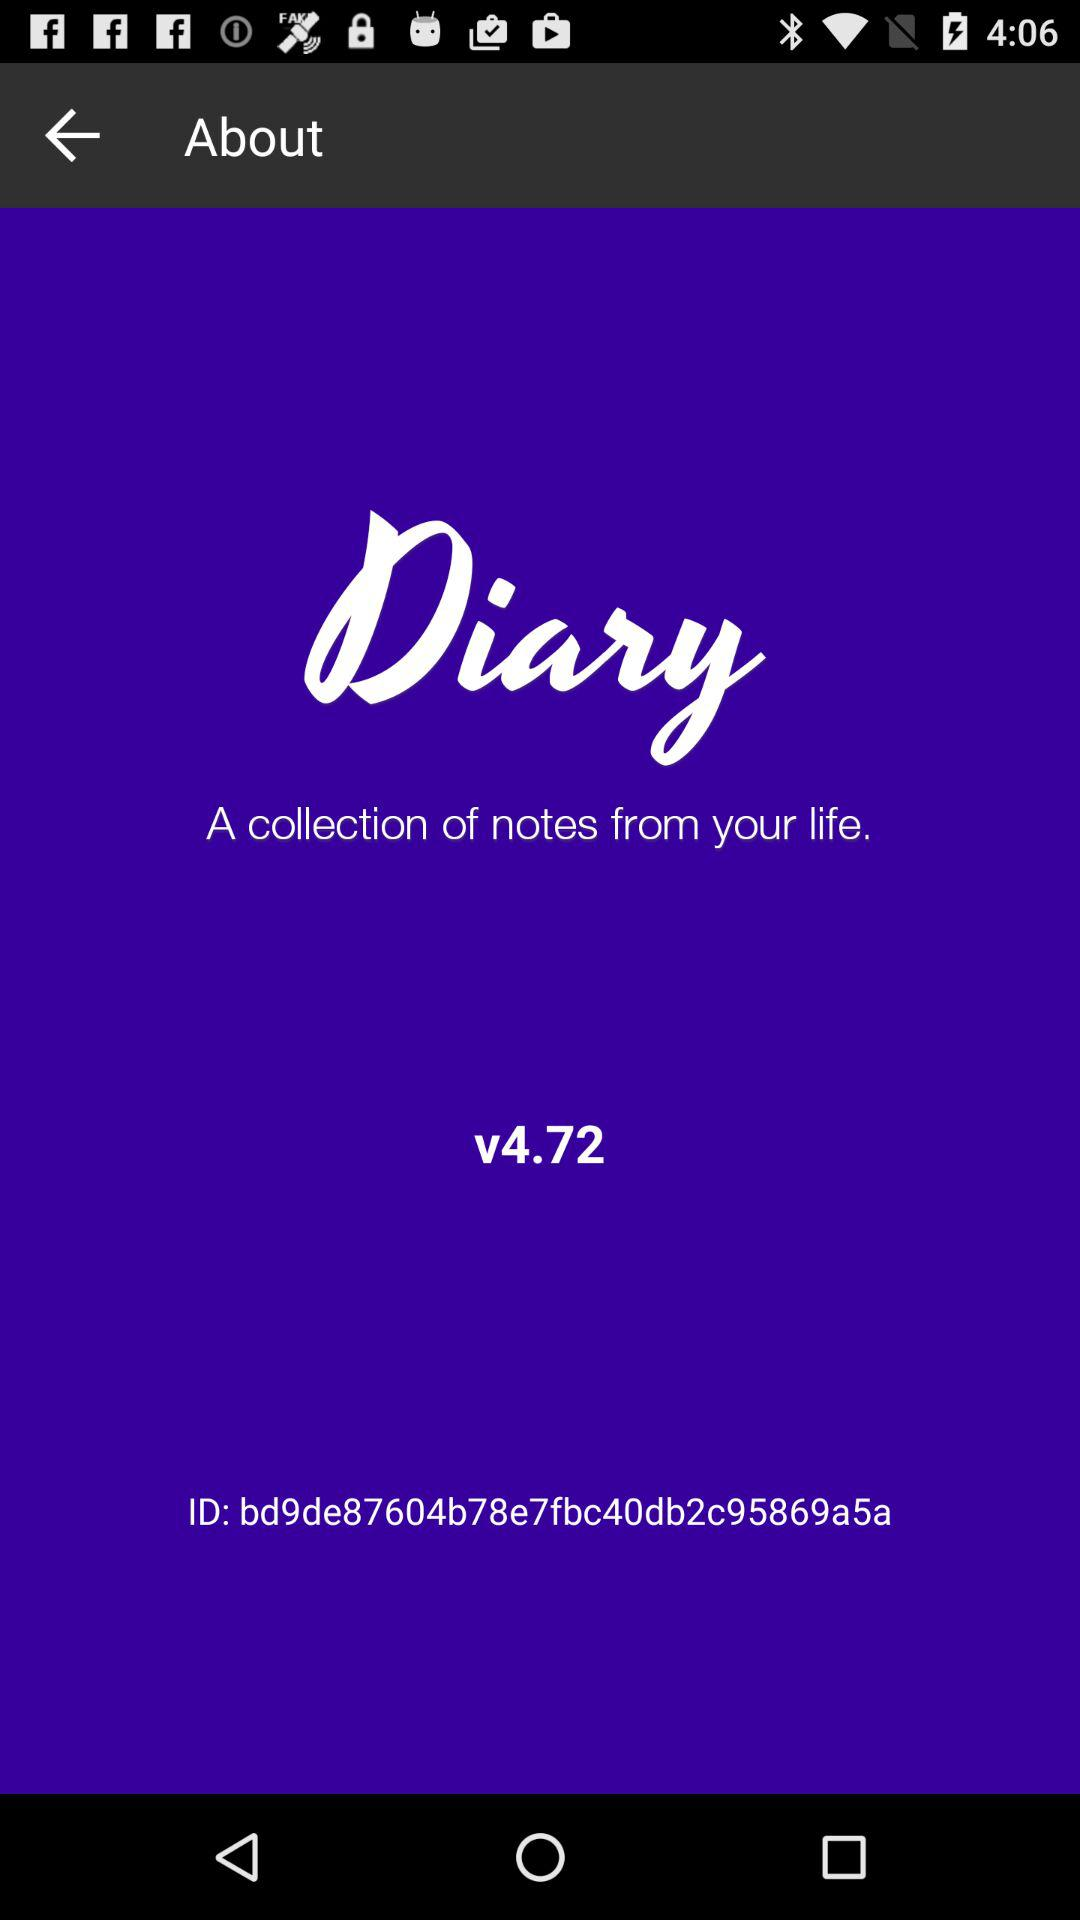What is the application name? The application name is "Diary". 